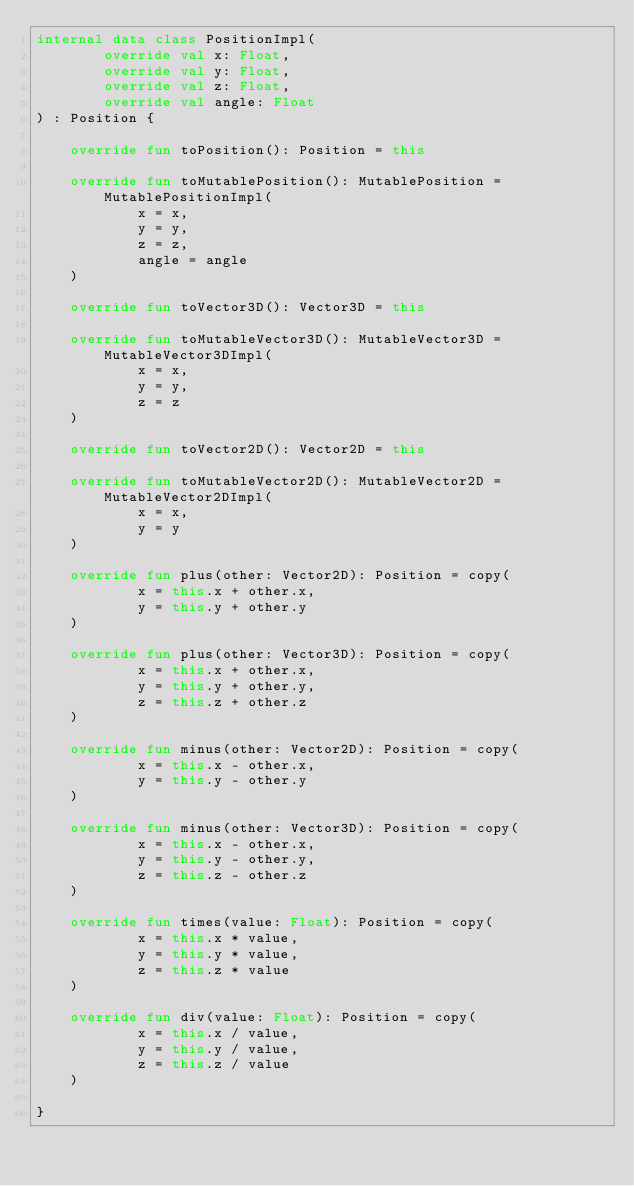<code> <loc_0><loc_0><loc_500><loc_500><_Kotlin_>internal data class PositionImpl(
        override val x: Float,
        override val y: Float,
        override val z: Float,
        override val angle: Float
) : Position {

    override fun toPosition(): Position = this

    override fun toMutablePosition(): MutablePosition = MutablePositionImpl(
            x = x,
            y = y,
            z = z,
            angle = angle
    )

    override fun toVector3D(): Vector3D = this

    override fun toMutableVector3D(): MutableVector3D = MutableVector3DImpl(
            x = x,
            y = y,
            z = z
    )

    override fun toVector2D(): Vector2D = this

    override fun toMutableVector2D(): MutableVector2D = MutableVector2DImpl(
            x = x,
            y = y
    )

    override fun plus(other: Vector2D): Position = copy(
            x = this.x + other.x,
            y = this.y + other.y
    )

    override fun plus(other: Vector3D): Position = copy(
            x = this.x + other.x,
            y = this.y + other.y,
            z = this.z + other.z
    )

    override fun minus(other: Vector2D): Position = copy(
            x = this.x - other.x,
            y = this.y - other.y
    )

    override fun minus(other: Vector3D): Position = copy(
            x = this.x - other.x,
            y = this.y - other.y,
            z = this.z - other.z
    )

    override fun times(value: Float): Position = copy(
            x = this.x * value,
            y = this.y * value,
            z = this.z * value
    )

    override fun div(value: Float): Position = copy(
            x = this.x / value,
            y = this.y / value,
            z = this.z / value
    )

}</code> 